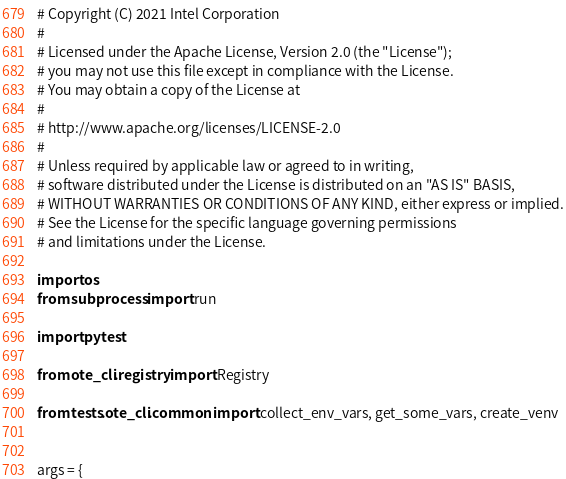<code> <loc_0><loc_0><loc_500><loc_500><_Python_># Copyright (C) 2021 Intel Corporation
#
# Licensed under the Apache License, Version 2.0 (the "License");
# you may not use this file except in compliance with the License.
# You may obtain a copy of the License at
#
# http://www.apache.org/licenses/LICENSE-2.0
#
# Unless required by applicable law or agreed to in writing,
# software distributed under the License is distributed on an "AS IS" BASIS,
# WITHOUT WARRANTIES OR CONDITIONS OF ANY KIND, either express or implied.
# See the License for the specific language governing permissions
# and limitations under the License.

import os
from subprocess import run

import pytest

from ote_cli.registry import Registry

from tests.ote_cli.common import collect_env_vars, get_some_vars, create_venv


args = {</code> 